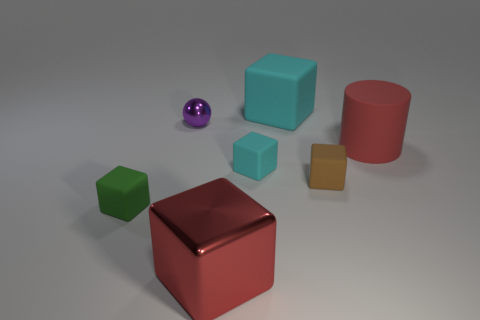What is the green thing made of?
Make the answer very short. Rubber. What is the material of the cyan thing that is the same size as the metal ball?
Offer a terse response. Rubber. Is there a shiny object of the same size as the red matte cylinder?
Make the answer very short. Yes. Are there the same number of purple spheres left of the brown thing and tiny brown objects that are on the left side of the purple metal ball?
Offer a very short reply. No. Is the number of large matte objects greater than the number of large red blocks?
Offer a terse response. Yes. What number of rubber things are big cyan cubes or small objects?
Offer a very short reply. 4. How many other tiny shiny things are the same color as the small metal thing?
Offer a terse response. 0. What material is the big thing behind the big red object on the right side of the cyan matte object that is behind the tiny cyan rubber cube made of?
Ensure brevity in your answer.  Rubber. What is the color of the tiny rubber thing to the right of the cyan block that is behind the small purple sphere?
Offer a terse response. Brown. How many small things are either rubber cubes or brown cubes?
Your answer should be compact. 3. 